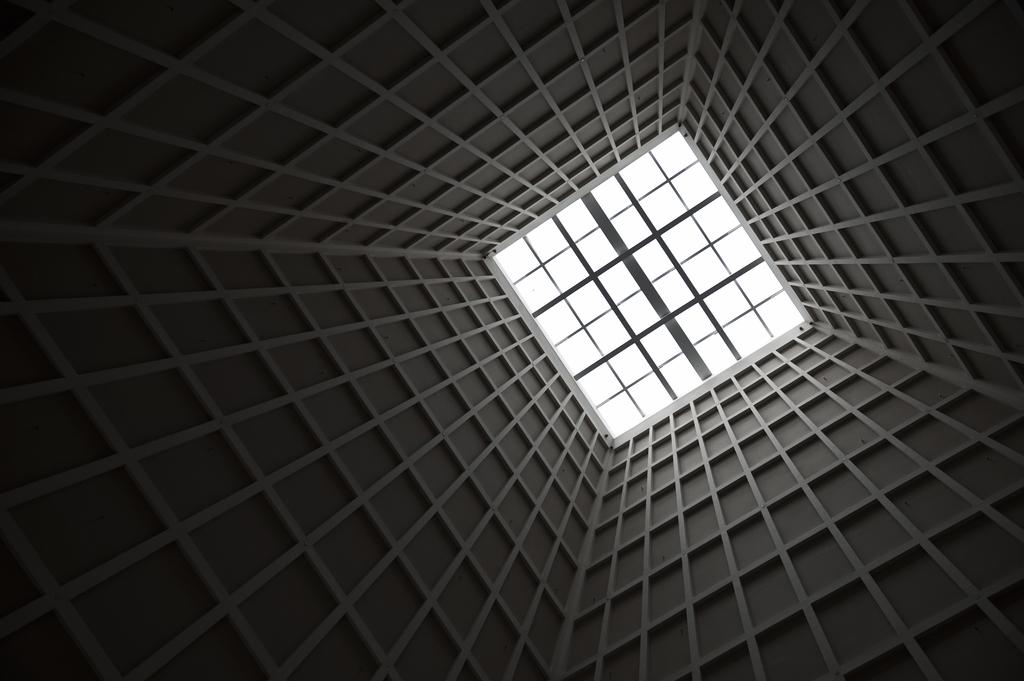What is located in the center of the image? There is a wall and a roof in the center of the image. Can you describe the wall in the image? The wall is in the center of the image. What is above the wall in the image? There is a roof above the wall in the image. What type of calculator can be seen on the roof in the image? There is no calculator present on the roof in the image. What is the view like from the wall in the image? The image does not provide a view from the wall, as it is a static image. 